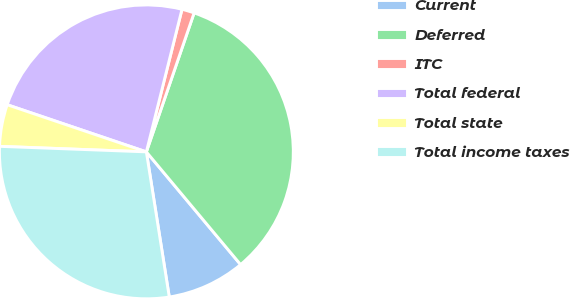Convert chart. <chart><loc_0><loc_0><loc_500><loc_500><pie_chart><fcel>Current<fcel>Deferred<fcel>ITC<fcel>Total federal<fcel>Total state<fcel>Total income taxes<nl><fcel>8.59%<fcel>33.65%<fcel>1.37%<fcel>23.7%<fcel>4.6%<fcel>28.09%<nl></chart> 